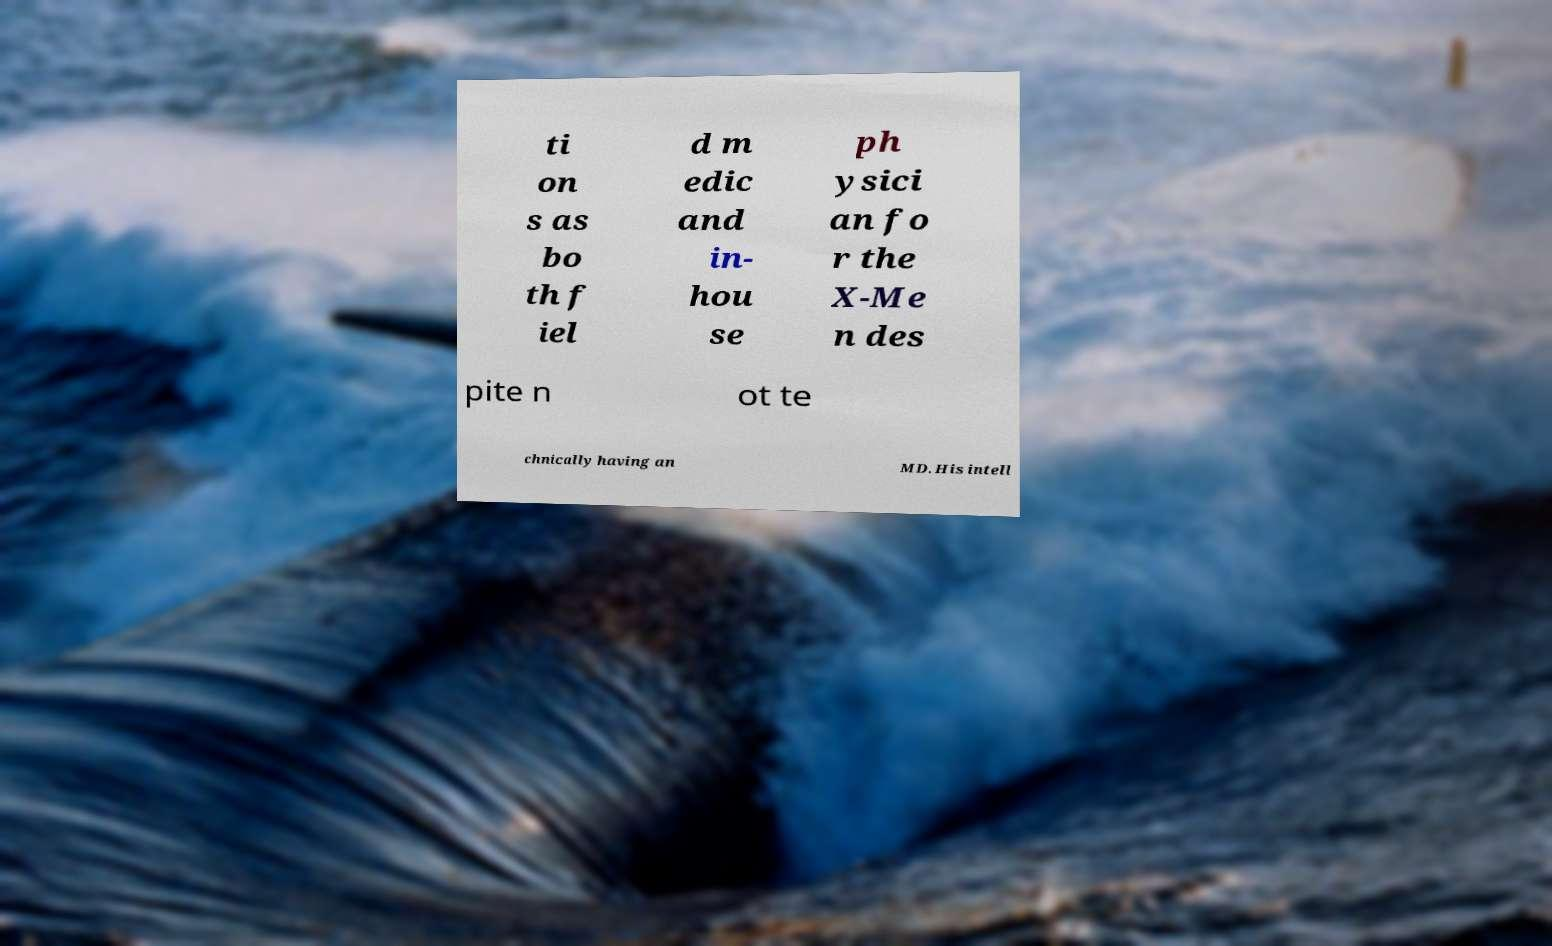Can you read and provide the text displayed in the image?This photo seems to have some interesting text. Can you extract and type it out for me? ti on s as bo th f iel d m edic and in- hou se ph ysici an fo r the X-Me n des pite n ot te chnically having an MD. His intell 